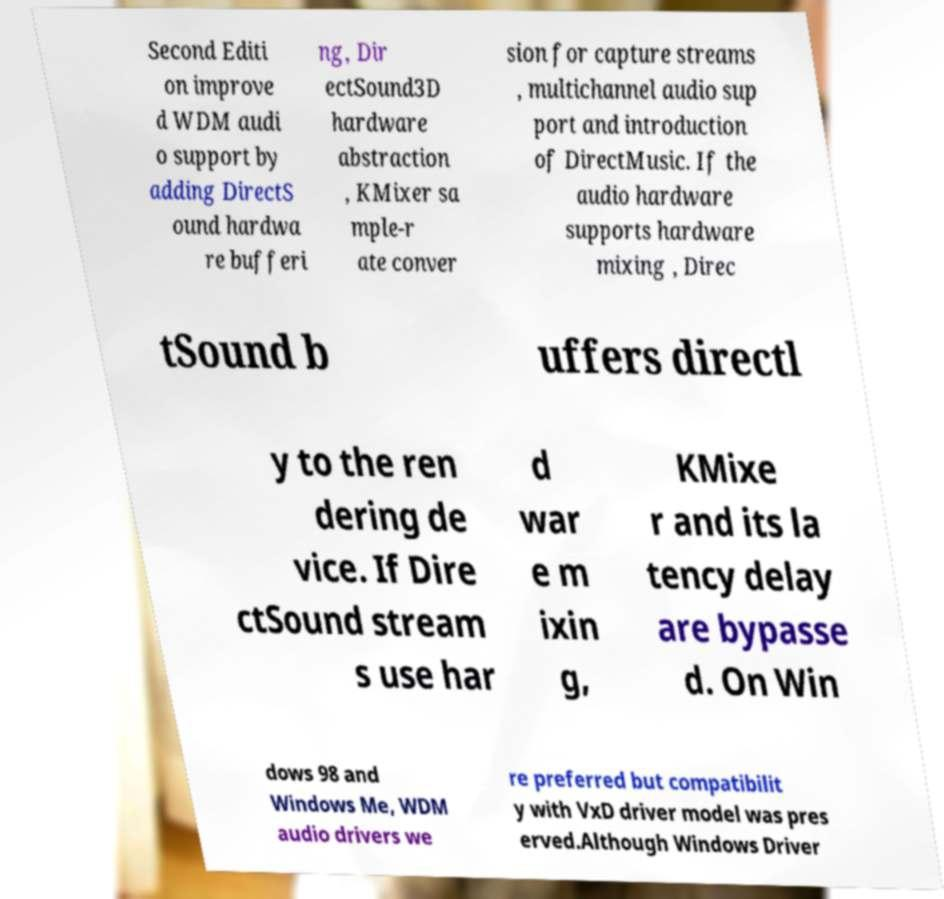For documentation purposes, I need the text within this image transcribed. Could you provide that? Second Editi on improve d WDM audi o support by adding DirectS ound hardwa re bufferi ng, Dir ectSound3D hardware abstraction , KMixer sa mple-r ate conver sion for capture streams , multichannel audio sup port and introduction of DirectMusic. If the audio hardware supports hardware mixing , Direc tSound b uffers directl y to the ren dering de vice. If Dire ctSound stream s use har d war e m ixin g, KMixe r and its la tency delay are bypasse d. On Win dows 98 and Windows Me, WDM audio drivers we re preferred but compatibilit y with VxD driver model was pres erved.Although Windows Driver 